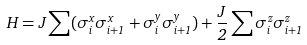<formula> <loc_0><loc_0><loc_500><loc_500>H = J \sum ( \sigma _ { i } ^ { x } \sigma _ { i + 1 } ^ { x } + \sigma _ { i } ^ { y } \sigma _ { i + 1 } ^ { y } ) + \frac { J } { 2 } \sum \sigma _ { i } ^ { z } \sigma _ { i + 1 } ^ { z }</formula> 